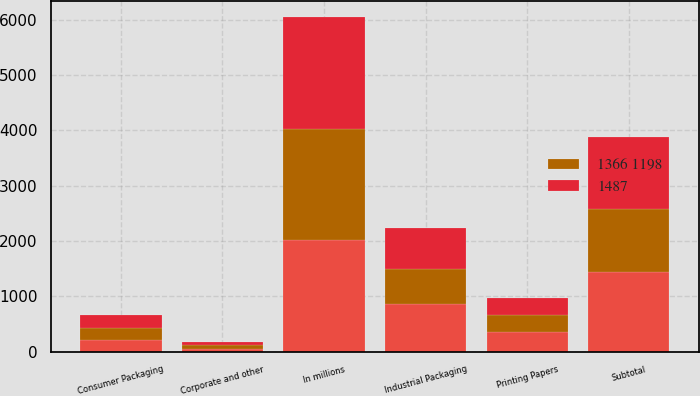Convert chart to OTSL. <chart><loc_0><loc_0><loc_500><loc_500><stacked_bar_chart><ecel><fcel>In millions<fcel>Industrial Packaging<fcel>Printing Papers<fcel>Consumer Packaging<fcel>Subtotal<fcel>Corporate and other<nl><fcel>nan<fcel>2015<fcel>858<fcel>361<fcel>216<fcel>1435<fcel>52<nl><fcel>1487<fcel>2014<fcel>754<fcel>318<fcel>233<fcel>1305<fcel>61<nl><fcel>1366 1198<fcel>2013<fcel>629<fcel>294<fcel>208<fcel>1140<fcel>58<nl></chart> 